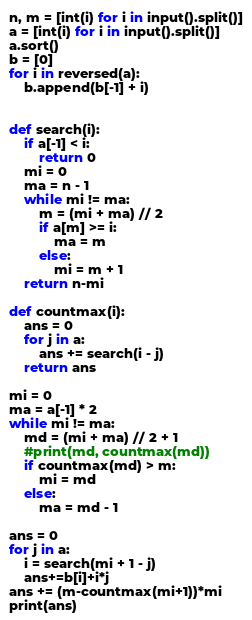Convert code to text. <code><loc_0><loc_0><loc_500><loc_500><_Python_>n, m = [int(i) for i in input().split()]
a = [int(i) for i in input().split()]
a.sort()
b = [0]
for i in reversed(a):
    b.append(b[-1] + i)


def search(i):
    if a[-1] < i:
        return 0
    mi = 0
    ma = n - 1
    while mi != ma:
        m = (mi + ma) // 2
        if a[m] >= i:
            ma = m
        else:
            mi = m + 1
    return n-mi

def countmax(i):
    ans = 0
    for j in a:
        ans += search(i - j)
    return ans

mi = 0
ma = a[-1] * 2
while mi != ma:
    md = (mi + ma) // 2 + 1
    #print(md, countmax(md))
    if countmax(md) > m:
        mi = md
    else:
        ma = md - 1

ans = 0
for j in a:
    i = search(mi + 1 - j)
    ans+=b[i]+i*j
ans += (m-countmax(mi+1))*mi
print(ans)
</code> 